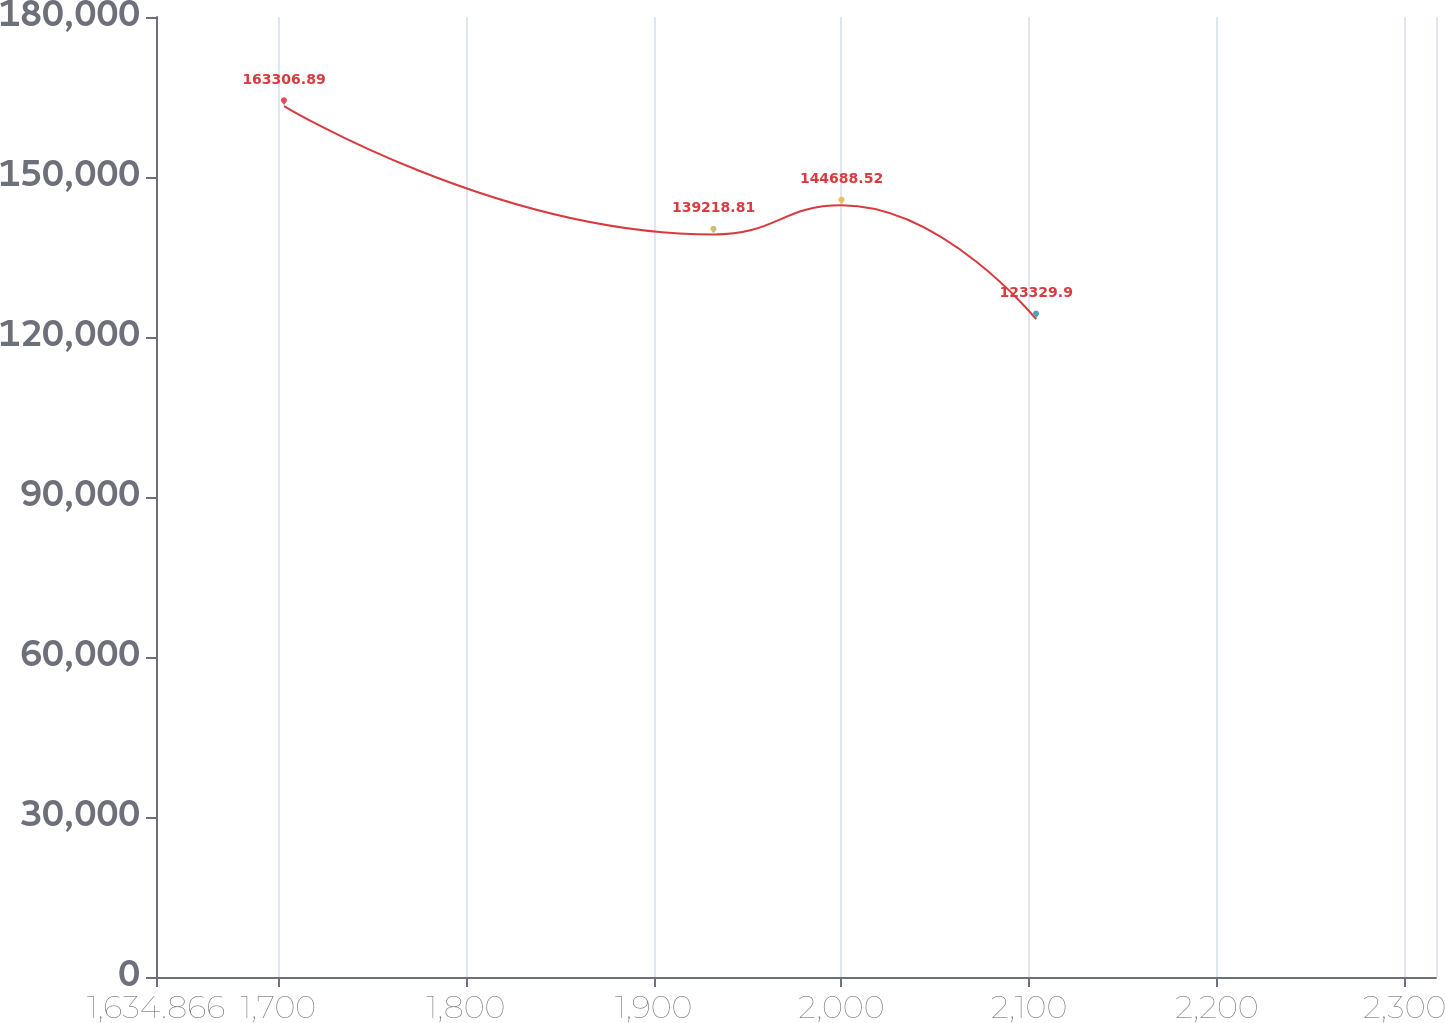Convert chart to OTSL. <chart><loc_0><loc_0><loc_500><loc_500><line_chart><ecel><fcel>Unnamed: 1<nl><fcel>1703.05<fcel>163307<nl><fcel>1931.85<fcel>139219<nl><fcel>2000.03<fcel>144689<nl><fcel>2103.71<fcel>123330<nl><fcel>2384.89<fcel>148686<nl></chart> 